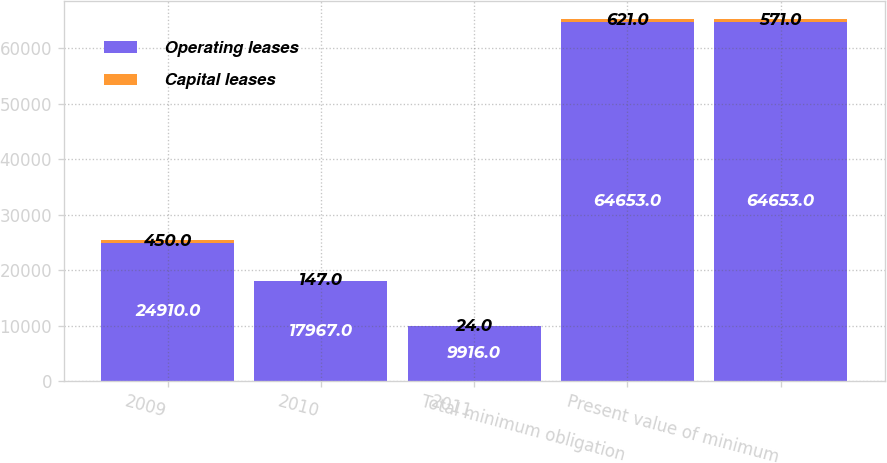Convert chart to OTSL. <chart><loc_0><loc_0><loc_500><loc_500><stacked_bar_chart><ecel><fcel>2009<fcel>2010<fcel>2011<fcel>Total minimum obligation<fcel>Present value of minimum<nl><fcel>Operating leases<fcel>24910<fcel>17967<fcel>9916<fcel>64653<fcel>64653<nl><fcel>Capital leases<fcel>450<fcel>147<fcel>24<fcel>621<fcel>571<nl></chart> 